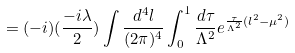Convert formula to latex. <formula><loc_0><loc_0><loc_500><loc_500>= ( - i ) ( \frac { - i \lambda } { 2 } ) \int \frac { d ^ { 4 } l } { ( 2 \pi ) ^ { 4 } } \int _ { 0 } ^ { 1 } \frac { d \tau } { \Lambda ^ { 2 } } e ^ { \frac { \tau } { \Lambda ^ { 2 } } ( l ^ { 2 } - { \mu } ^ { 2 } ) }</formula> 